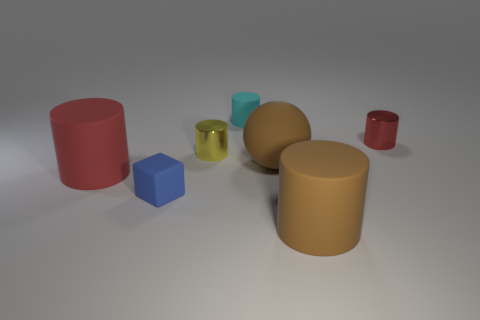What could be the possible context or theme this image is trying to convey? The image seems to present a study of geometric forms, color contrasts, and texture variations. It could be an artistic composition meant for visual analysis or an educational display illustrating different properties of objects in a controlled lighting environment. 